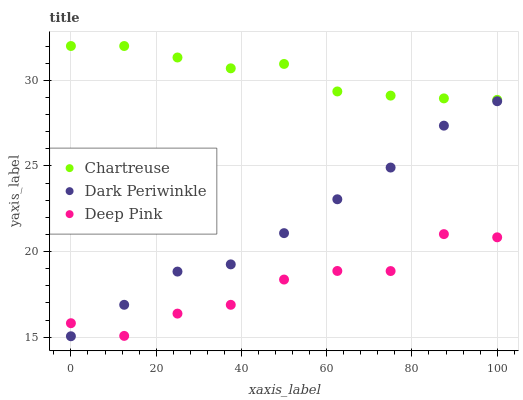Does Deep Pink have the minimum area under the curve?
Answer yes or no. Yes. Does Chartreuse have the maximum area under the curve?
Answer yes or no. Yes. Does Dark Periwinkle have the minimum area under the curve?
Answer yes or no. No. Does Dark Periwinkle have the maximum area under the curve?
Answer yes or no. No. Is Dark Periwinkle the smoothest?
Answer yes or no. Yes. Is Deep Pink the roughest?
Answer yes or no. Yes. Is Deep Pink the smoothest?
Answer yes or no. No. Is Dark Periwinkle the roughest?
Answer yes or no. No. Does Dark Periwinkle have the lowest value?
Answer yes or no. Yes. Does Deep Pink have the lowest value?
Answer yes or no. No. Does Chartreuse have the highest value?
Answer yes or no. Yes. Does Dark Periwinkle have the highest value?
Answer yes or no. No. Is Deep Pink less than Chartreuse?
Answer yes or no. Yes. Is Chartreuse greater than Dark Periwinkle?
Answer yes or no. Yes. Does Deep Pink intersect Dark Periwinkle?
Answer yes or no. Yes. Is Deep Pink less than Dark Periwinkle?
Answer yes or no. No. Is Deep Pink greater than Dark Periwinkle?
Answer yes or no. No. Does Deep Pink intersect Chartreuse?
Answer yes or no. No. 